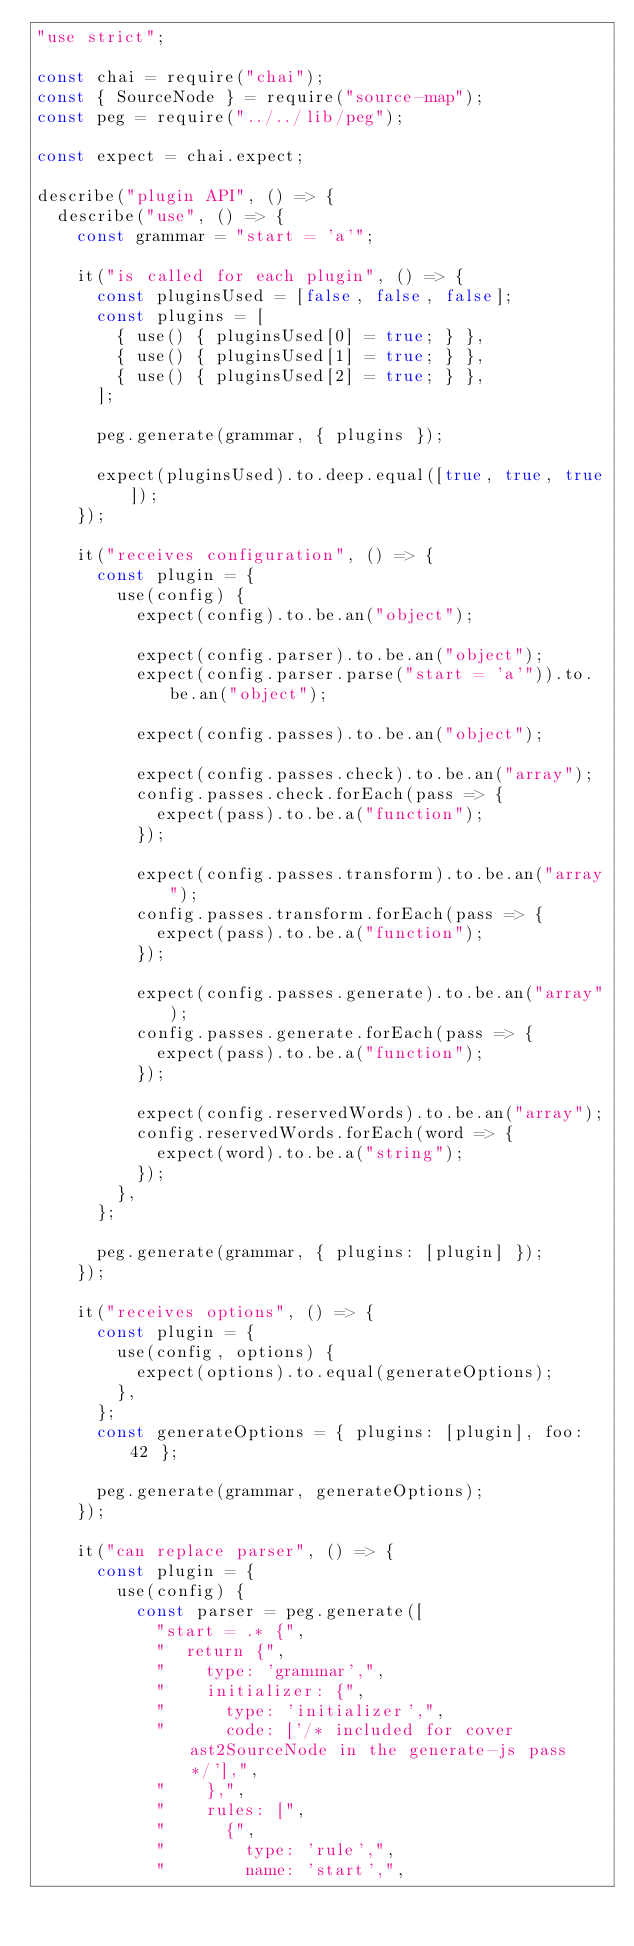<code> <loc_0><loc_0><loc_500><loc_500><_JavaScript_>"use strict";

const chai = require("chai");
const { SourceNode } = require("source-map");
const peg = require("../../lib/peg");

const expect = chai.expect;

describe("plugin API", () => {
  describe("use", () => {
    const grammar = "start = 'a'";

    it("is called for each plugin", () => {
      const pluginsUsed = [false, false, false];
      const plugins = [
        { use() { pluginsUsed[0] = true; } },
        { use() { pluginsUsed[1] = true; } },
        { use() { pluginsUsed[2] = true; } },
      ];

      peg.generate(grammar, { plugins });

      expect(pluginsUsed).to.deep.equal([true, true, true]);
    });

    it("receives configuration", () => {
      const plugin = {
        use(config) {
          expect(config).to.be.an("object");

          expect(config.parser).to.be.an("object");
          expect(config.parser.parse("start = 'a'")).to.be.an("object");

          expect(config.passes).to.be.an("object");

          expect(config.passes.check).to.be.an("array");
          config.passes.check.forEach(pass => {
            expect(pass).to.be.a("function");
          });

          expect(config.passes.transform).to.be.an("array");
          config.passes.transform.forEach(pass => {
            expect(pass).to.be.a("function");
          });

          expect(config.passes.generate).to.be.an("array");
          config.passes.generate.forEach(pass => {
            expect(pass).to.be.a("function");
          });

          expect(config.reservedWords).to.be.an("array");
          config.reservedWords.forEach(word => {
            expect(word).to.be.a("string");
          });
        },
      };

      peg.generate(grammar, { plugins: [plugin] });
    });

    it("receives options", () => {
      const plugin = {
        use(config, options) {
          expect(options).to.equal(generateOptions);
        },
      };
      const generateOptions = { plugins: [plugin], foo: 42 };

      peg.generate(grammar, generateOptions);
    });

    it("can replace parser", () => {
      const plugin = {
        use(config) {
          const parser = peg.generate([
            "start = .* {",
            "  return {",
            "    type: 'grammar',",
            "    initializer: {",
            "      type: 'initializer',",
            "      code: ['/* included for cover ast2SourceNode in the generate-js pass */'],",
            "    },",
            "    rules: [",
            "      {",
            "        type: 'rule',",
            "        name: 'start',",</code> 